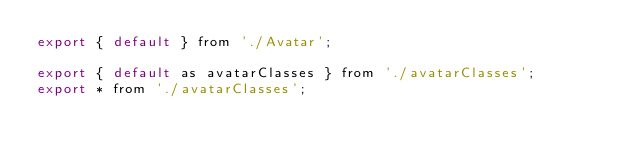<code> <loc_0><loc_0><loc_500><loc_500><_JavaScript_>export { default } from './Avatar';

export { default as avatarClasses } from './avatarClasses';
export * from './avatarClasses';
</code> 